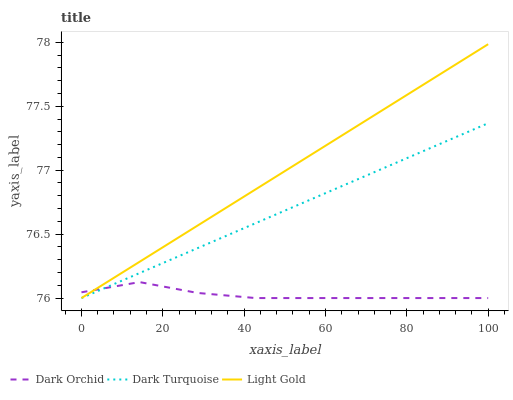Does Light Gold have the minimum area under the curve?
Answer yes or no. No. Does Dark Orchid have the maximum area under the curve?
Answer yes or no. No. Is Dark Orchid the smoothest?
Answer yes or no. No. Is Light Gold the roughest?
Answer yes or no. No. Does Dark Orchid have the highest value?
Answer yes or no. No. 